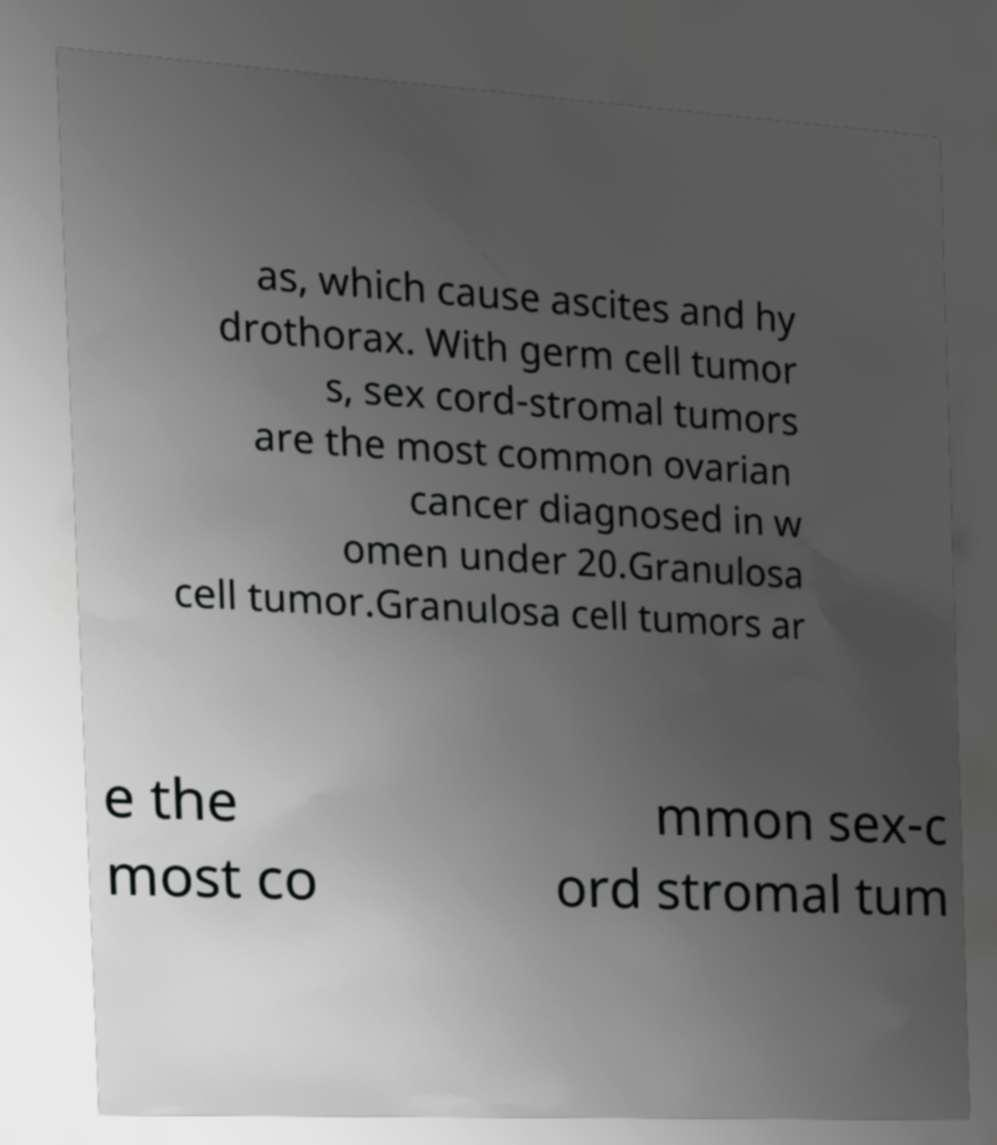Could you extract and type out the text from this image? as, which cause ascites and hy drothorax. With germ cell tumor s, sex cord-stromal tumors are the most common ovarian cancer diagnosed in w omen under 20.Granulosa cell tumor.Granulosa cell tumors ar e the most co mmon sex-c ord stromal tum 